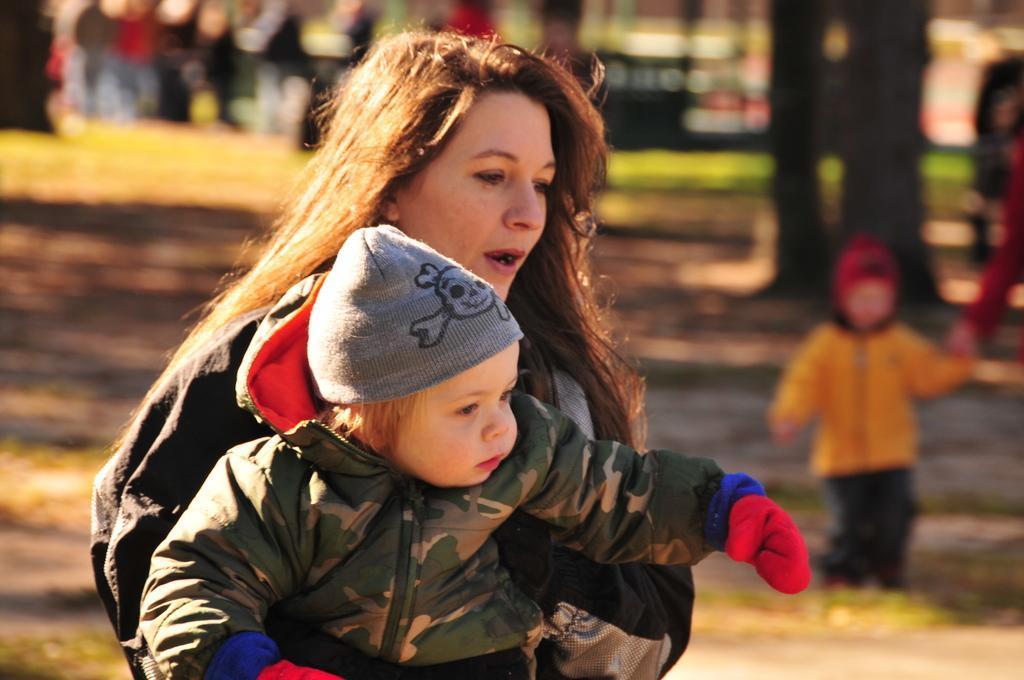Describe this image in one or two sentences. In this picture I can see a woman holding a baby and baby wearing a cap and on the right side I can see a baby, baby holding a person hand on the right side, background is too blur. 